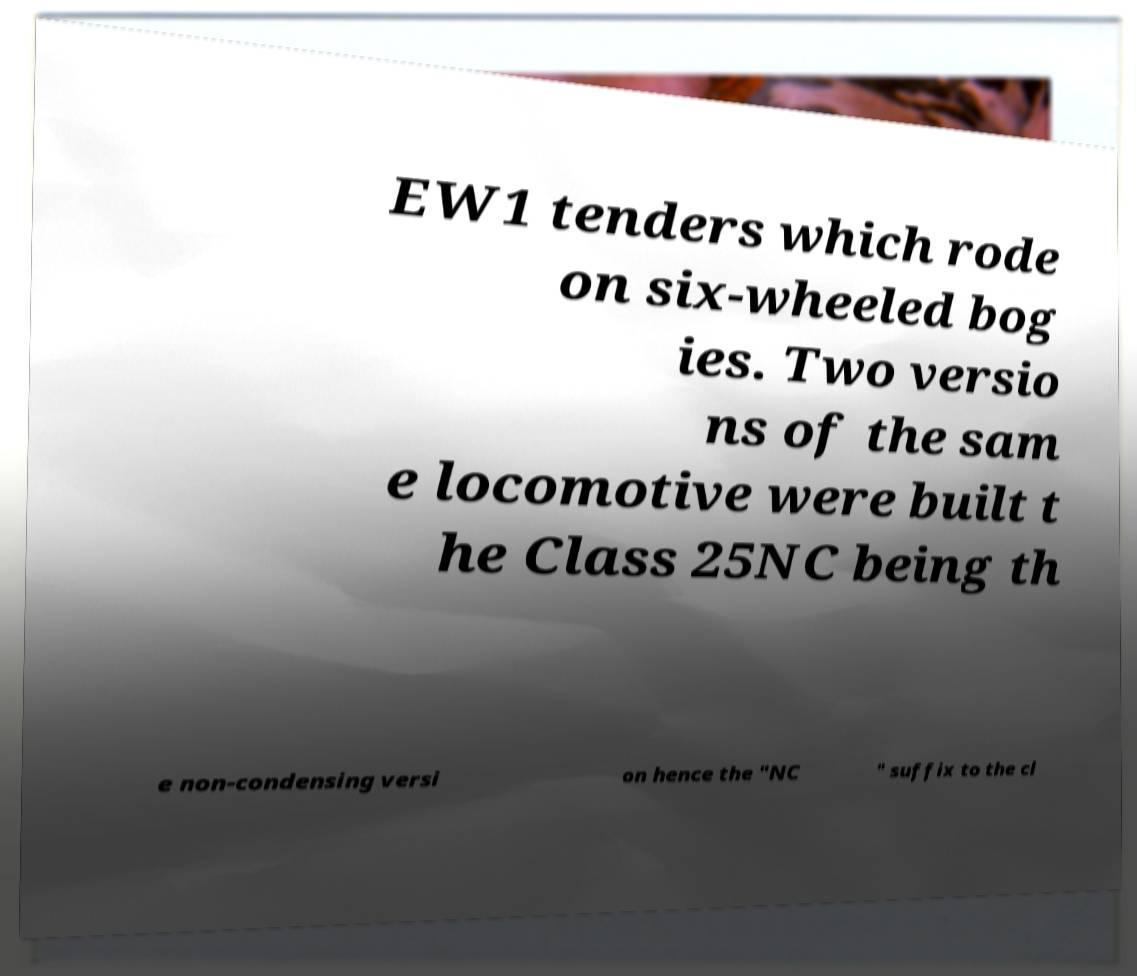There's text embedded in this image that I need extracted. Can you transcribe it verbatim? EW1 tenders which rode on six-wheeled bog ies. Two versio ns of the sam e locomotive were built t he Class 25NC being th e non-condensing versi on hence the "NC " suffix to the cl 